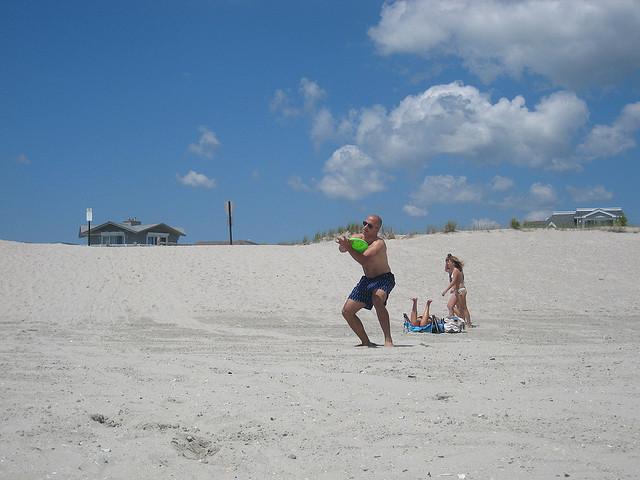What is behind the catcher?
Give a very brief answer. People. What activity is the man engaged in?
Short answer required. Frisbee. Is the man skiing?
Quick response, please. No. Are they playing in the sand?
Answer briefly. Yes. Is it cold outside?
Concise answer only. No. Where is the frisbee?
Be succinct. Man's hands. Are the horseback riding?
Answer briefly. No. What is the man catching in his hands?
Give a very brief answer. Frisbee. What are the people holding in their hands?
Answer briefly. Frisbee. Is the man cold?
Concise answer only. No. Is there a house in the back?
Keep it brief. Yes. What is the pink item by the child's feet?
Write a very short answer. Sand. Is the man flying a kite?
Quick response, please. No. 